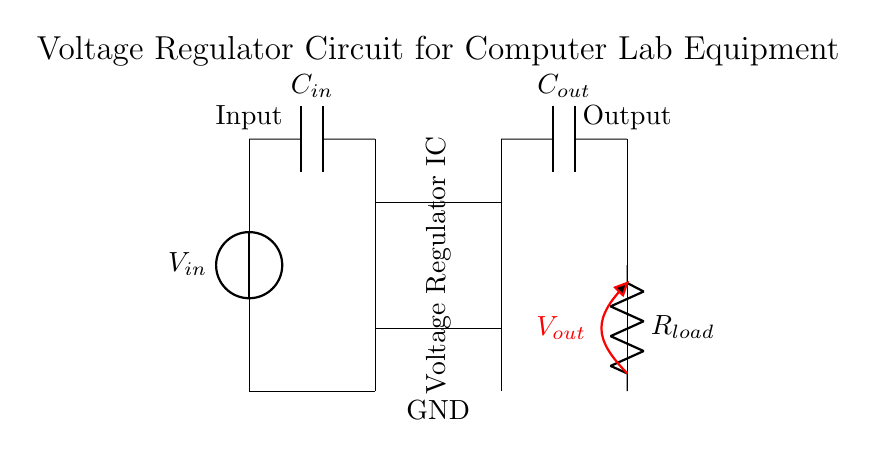What is the purpose of the voltage regulator in this circuit? The voltage regulator's purpose is to maintain a stable output voltage regardless of variations in input voltage or load conditions, ensuring sensitive equipment operates correctly.
Answer: Stable output voltage What is the value of the input capacitor labeled in the diagram? The diagram labels the input capacitor as C-in, indicating it is used to filter noise from the input voltage and maintain stability of the voltage regulator. However, the exact value is not given in the diagram, so it cannot be specified.
Answer: C-in How many capacitors are there in the circuit? There are two capacitors in the circuit: the input capacitor (C-in) and the output capacitor (C-out), both fundamental for the regulator's operation.
Answer: Two What voltage is shown at the output of the circuit? The circuit diagram labels the output voltage as V-out, indicating the voltage supplied to the load (R-load). The exact numerical value is not indicated on the diagram.
Answer: V-out What component is connected to the output of the voltage regulator? The component connected to the output of the voltage regulator is the load resistor (R-load), which represents the equipment that will utilize the regulated voltage.
Answer: Load resistor What happens if the input voltage exceeds the maximum rating of the voltage regulator? If the input voltage exceeds the maximum rating, it may damage the voltage regulator and the sensitive equipment connected to it, possibly leading to performance issues or failure.
Answer: Damage may occur What does the ground label indicate in this circuit? The ground label indicates the reference point for the circuit's voltage levels, serving as the common return path for electric current, which is essential for circuit stability and operation.
Answer: Common return path 